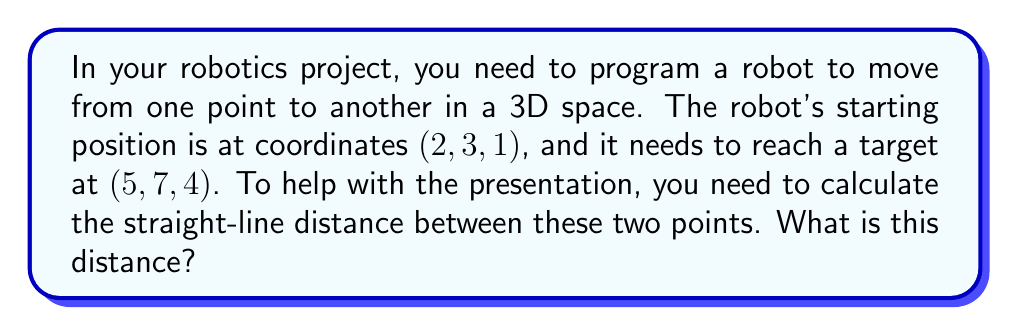Can you solve this math problem? Let's approach this step-by-step:

1) The formula for finding the distance between two points in 3D space is:

   $$d = \sqrt{(x_2-x_1)^2 + (y_2-y_1)^2 + (z_2-z_1)^2}$$

   Where $(x_1, y_1, z_1)$ is the starting point and $(x_2, y_2, z_2)$ is the ending point.

2) We have:
   Starting point $(x_1, y_1, z_1) = (2, 3, 1)$
   Ending point $(x_2, y_2, z_2) = (5, 7, 4)$

3) Let's substitute these into our formula:

   $$d = \sqrt{(5-2)^2 + (7-3)^2 + (4-1)^2}$$

4) Simplify the expressions inside the parentheses:

   $$d = \sqrt{3^2 + 4^2 + 3^2}$$

5) Calculate the squares:

   $$d = \sqrt{9 + 16 + 9}$$

6) Add the numbers under the square root:

   $$d = \sqrt{34}$$

7) The square root of 34 doesn't simplify to a nice whole number, so we'll leave it as is.

This $\sqrt{34}$ represents the exact distance in the same units as the coordinate system.
Answer: $\sqrt{34}$ units 